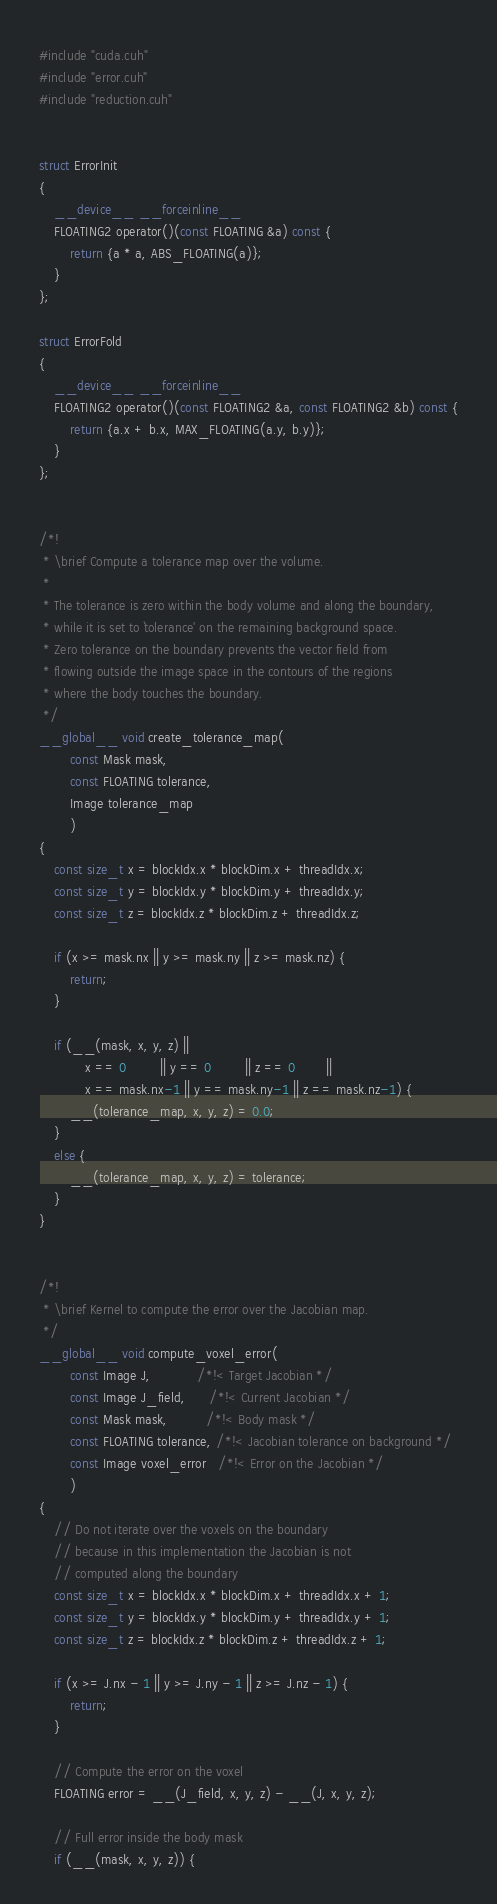<code> <loc_0><loc_0><loc_500><loc_500><_Cuda_>#include "cuda.cuh"
#include "error.cuh"
#include "reduction.cuh"


struct ErrorInit
{
    __device__ __forceinline__
    FLOATING2 operator()(const FLOATING &a) const {
        return {a * a, ABS_FLOATING(a)};
    }
};

struct ErrorFold
{
    __device__ __forceinline__
    FLOATING2 operator()(const FLOATING2 &a, const FLOATING2 &b) const {
        return {a.x + b.x, MAX_FLOATING(a.y, b.y)};
    }
};


/*!
 * \brief Compute a tolerance map over the volume.
 *
 * The tolerance is zero within the body volume and along the boundary,
 * while it is set to `tolerance' on the remaining background space.
 * Zero tolerance on the boundary prevents the vector field from 
 * flowing outside the image space in the contours of the regions
 * where the body touches the boundary.
 */
__global__ void create_tolerance_map(
        const Mask mask,
        const FLOATING tolerance,
        Image tolerance_map
        )
{
    const size_t x = blockIdx.x * blockDim.x + threadIdx.x;
    const size_t y = blockIdx.y * blockDim.y + threadIdx.y;
    const size_t z = blockIdx.z * blockDim.z + threadIdx.z;

    if (x >= mask.nx || y >= mask.ny || z >= mask.nz) {
        return;
    }
    
    if (__(mask, x, y, z) || 
            x == 0         || y == 0         || z == 0        || 
            x == mask.nx-1 || y == mask.ny-1 || z == mask.nz-1) {
        __(tolerance_map, x, y, z) = 0.0;
    }
    else {
        __(tolerance_map, x, y, z) = tolerance;
    }
}

 
/*!
 * \brief Kernel to compute the error over the Jacobian map.
 */
__global__ void compute_voxel_error(
        const Image J,            /*!< Target Jacobian */
        const Image J_field,      /*!< Current Jacobian */
        const Mask mask,          /*!< Body mask */
        const FLOATING tolerance, /*!< Jacobian tolerance on background */
        const Image voxel_error   /*!< Error on the Jacobian */
        )
{
    // Do not iterate over the voxels on the boundary
    // because in this implementation the Jacobian is not
    // computed along the boundary
    const size_t x = blockIdx.x * blockDim.x + threadIdx.x + 1;
    const size_t y = blockIdx.y * blockDim.y + threadIdx.y + 1;
    const size_t z = blockIdx.z * blockDim.z + threadIdx.z + 1;

    if (x >= J.nx - 1 || y >= J.ny - 1 || z >= J.nz - 1) {
        return;
    }

    // Compute the error on the voxel
    FLOATING error = __(J_field, x, y, z) - __(J, x, y, z);

    // Full error inside the body mask
    if (__(mask, x, y, z)) {</code> 